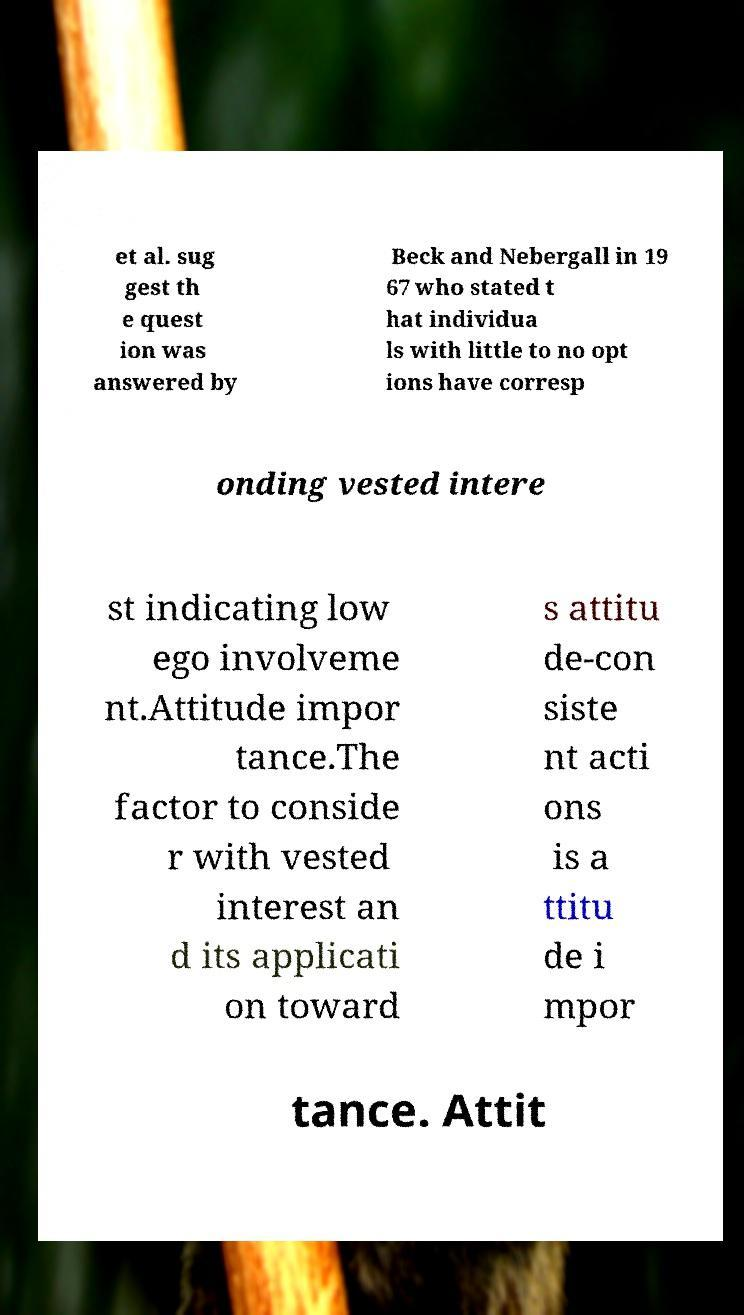There's text embedded in this image that I need extracted. Can you transcribe it verbatim? et al. sug gest th e quest ion was answered by Beck and Nebergall in 19 67 who stated t hat individua ls with little to no opt ions have corresp onding vested intere st indicating low ego involveme nt.Attitude impor tance.The factor to conside r with vested interest an d its applicati on toward s attitu de-con siste nt acti ons is a ttitu de i mpor tance. Attit 